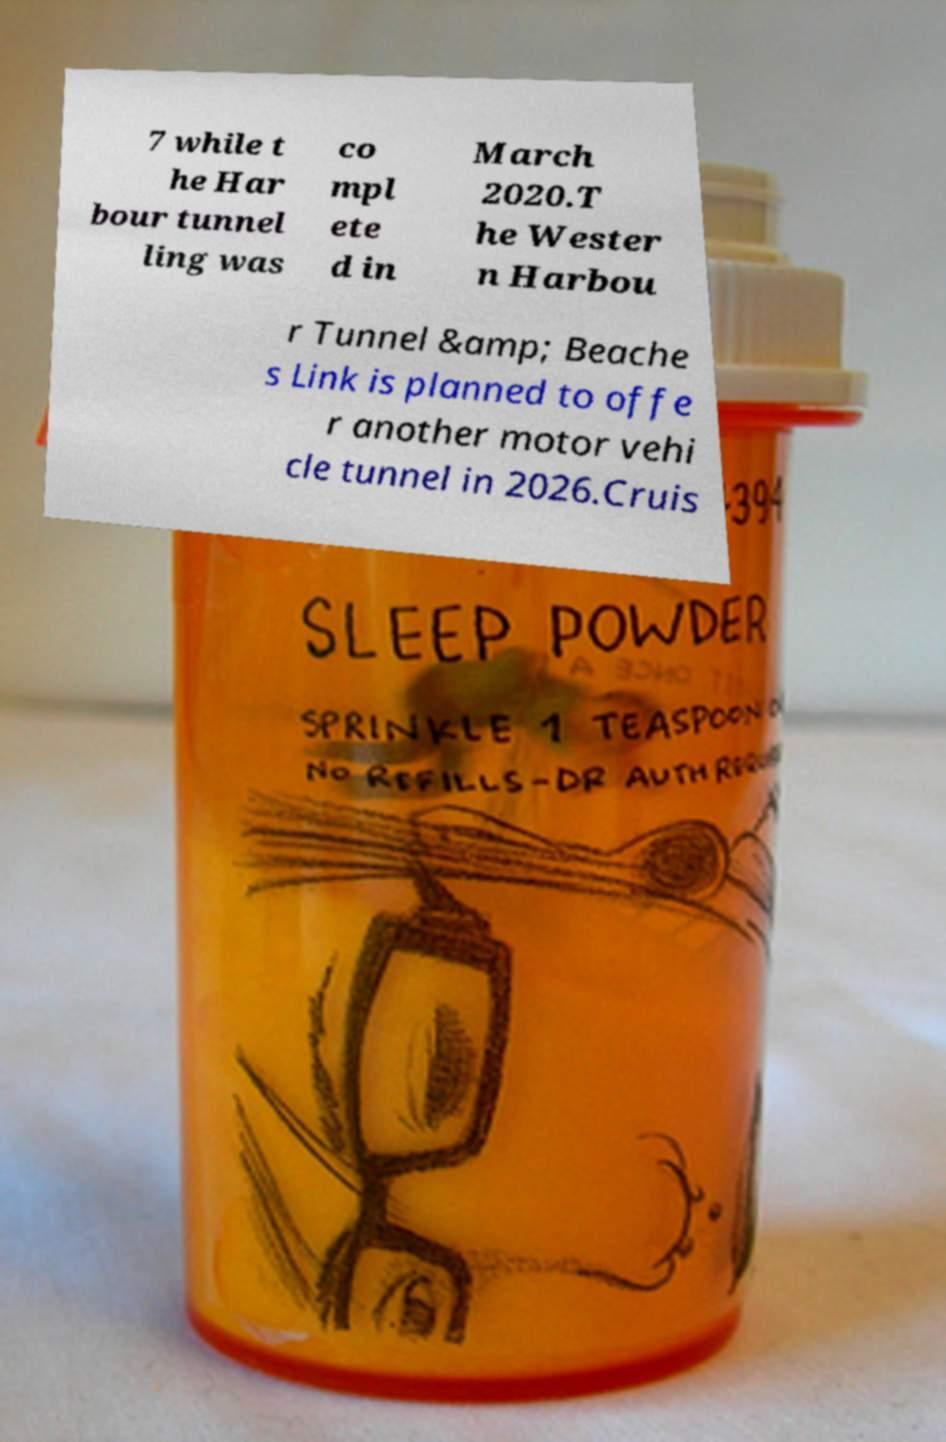Please identify and transcribe the text found in this image. 7 while t he Har bour tunnel ling was co mpl ete d in March 2020.T he Wester n Harbou r Tunnel &amp; Beache s Link is planned to offe r another motor vehi cle tunnel in 2026.Cruis 